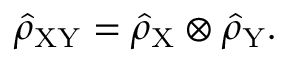Convert formula to latex. <formula><loc_0><loc_0><loc_500><loc_500>\hat { \rho } _ { X Y } = \hat { \rho } _ { X } \otimes \hat { \rho } _ { Y } .</formula> 